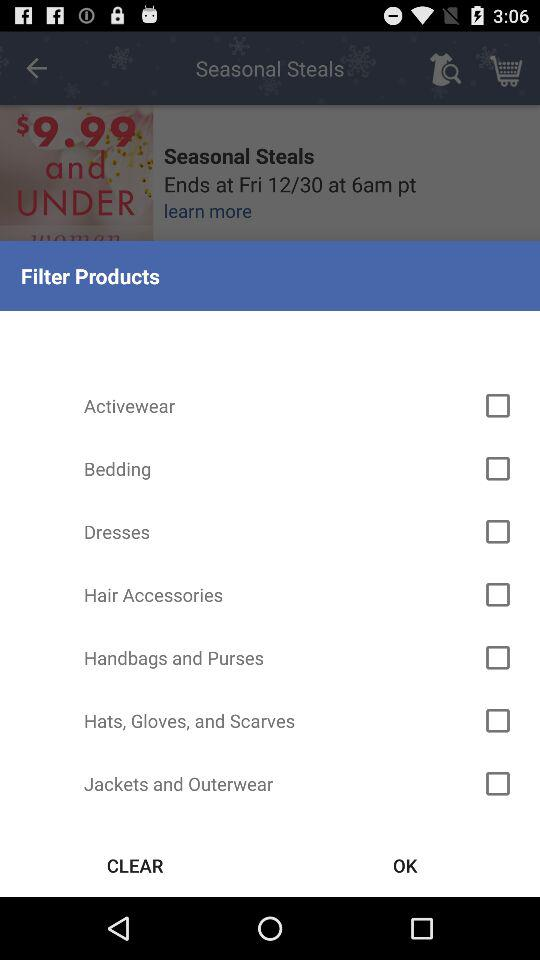Is "Dresses" checked or not?
Answer the question using a single word or phrase. "Dresses" is unchecked. 